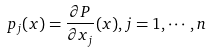Convert formula to latex. <formula><loc_0><loc_0><loc_500><loc_500>p _ { j } ( x ) = \frac { \partial P } { \partial x _ { j } } ( x ) , j = 1 , \cdots , n</formula> 